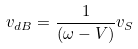<formula> <loc_0><loc_0><loc_500><loc_500>v _ { d B } = \frac { 1 } { ( \omega - V ) } v _ { S }</formula> 